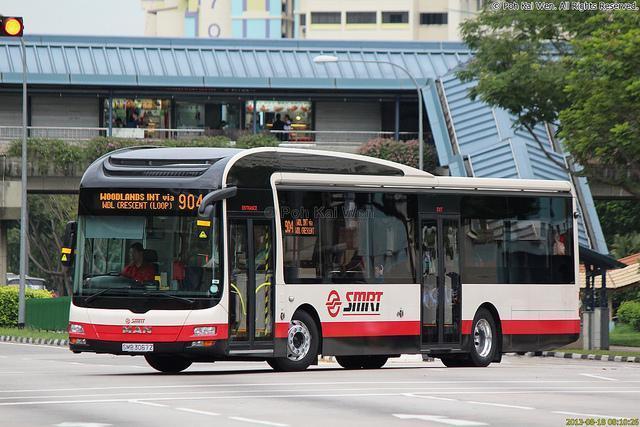How many tires are on the bus?
Give a very brief answer. 6. How many black cars are in the picture?
Give a very brief answer. 0. 